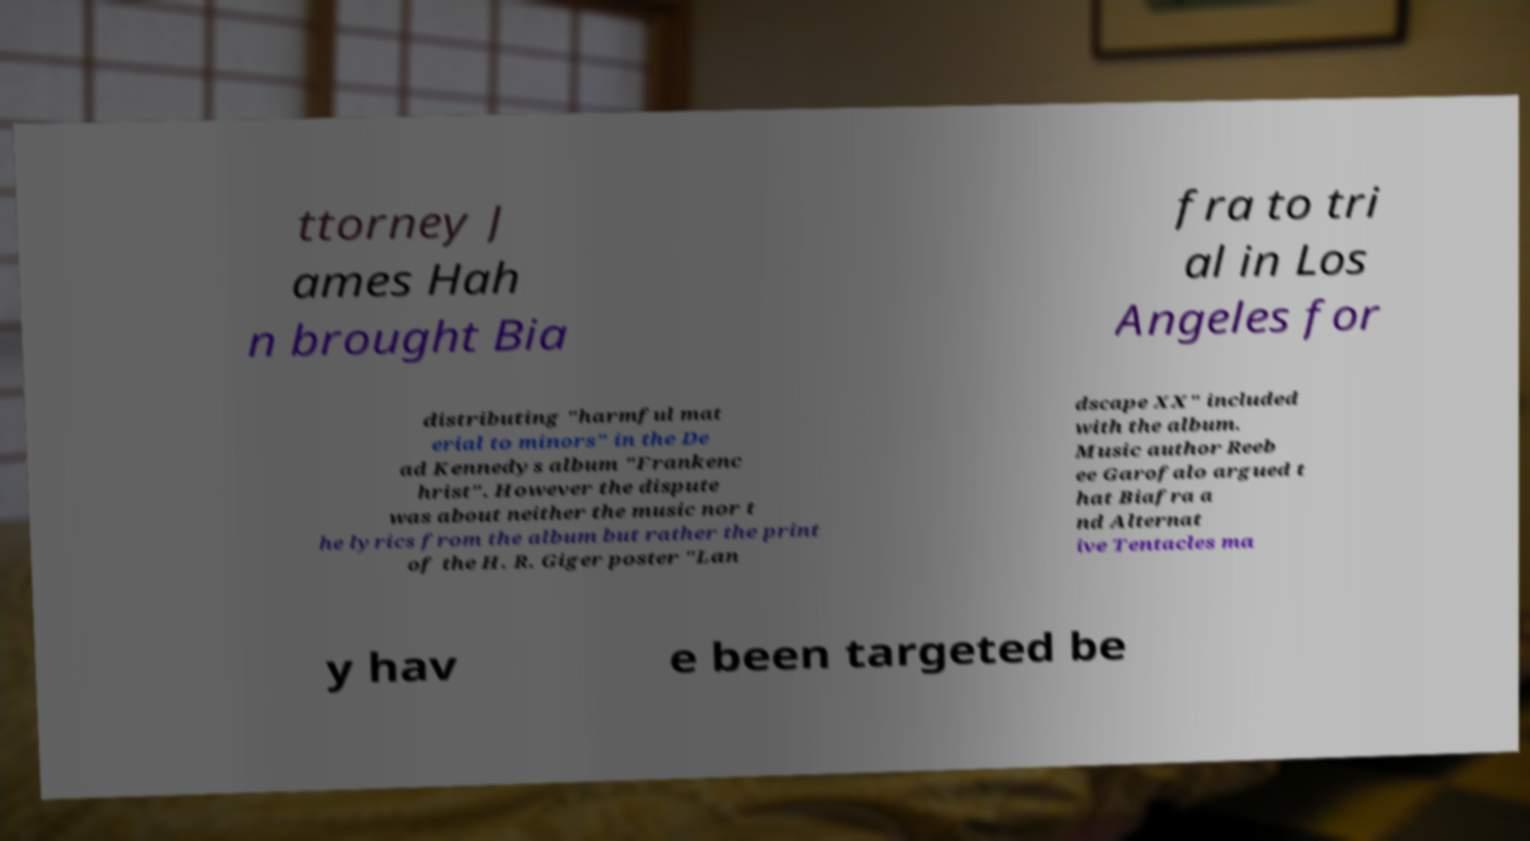Could you assist in decoding the text presented in this image and type it out clearly? ttorney J ames Hah n brought Bia fra to tri al in Los Angeles for distributing "harmful mat erial to minors" in the De ad Kennedys album "Frankenc hrist". However the dispute was about neither the music nor t he lyrics from the album but rather the print of the H. R. Giger poster "Lan dscape XX" included with the album. Music author Reeb ee Garofalo argued t hat Biafra a nd Alternat ive Tentacles ma y hav e been targeted be 